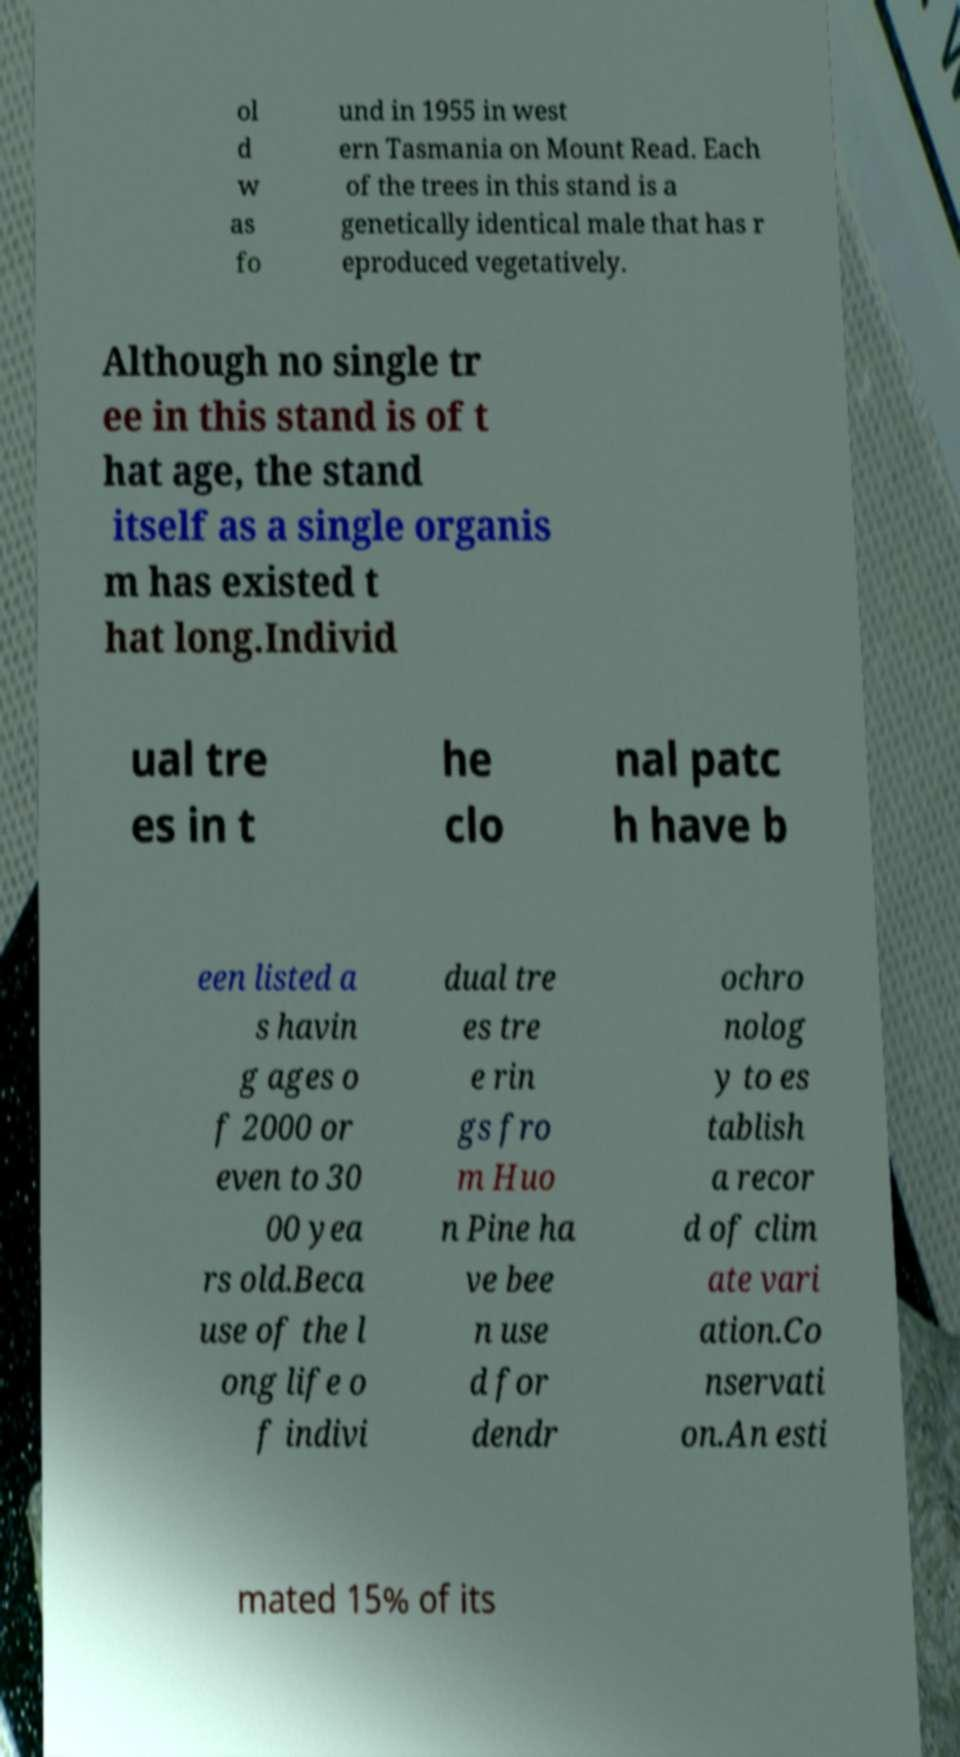Can you accurately transcribe the text from the provided image for me? ol d w as fo und in 1955 in west ern Tasmania on Mount Read. Each of the trees in this stand is a genetically identical male that has r eproduced vegetatively. Although no single tr ee in this stand is of t hat age, the stand itself as a single organis m has existed t hat long.Individ ual tre es in t he clo nal patc h have b een listed a s havin g ages o f 2000 or even to 30 00 yea rs old.Beca use of the l ong life o f indivi dual tre es tre e rin gs fro m Huo n Pine ha ve bee n use d for dendr ochro nolog y to es tablish a recor d of clim ate vari ation.Co nservati on.An esti mated 15% of its 